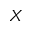Convert formula to latex. <formula><loc_0><loc_0><loc_500><loc_500>X</formula> 